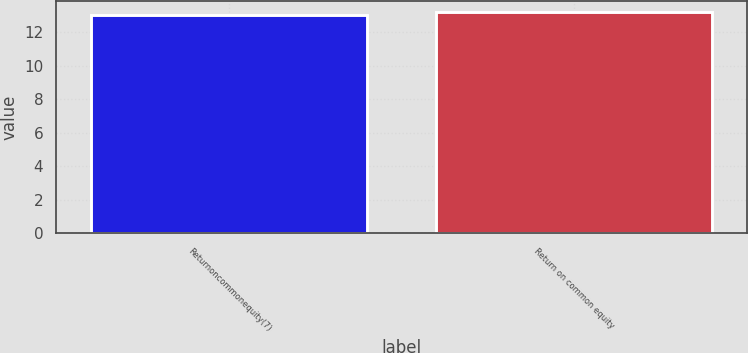Convert chart. <chart><loc_0><loc_0><loc_500><loc_500><bar_chart><fcel>Returnoncommonequity(7)<fcel>Return on common equity<nl><fcel>13<fcel>13.2<nl></chart> 